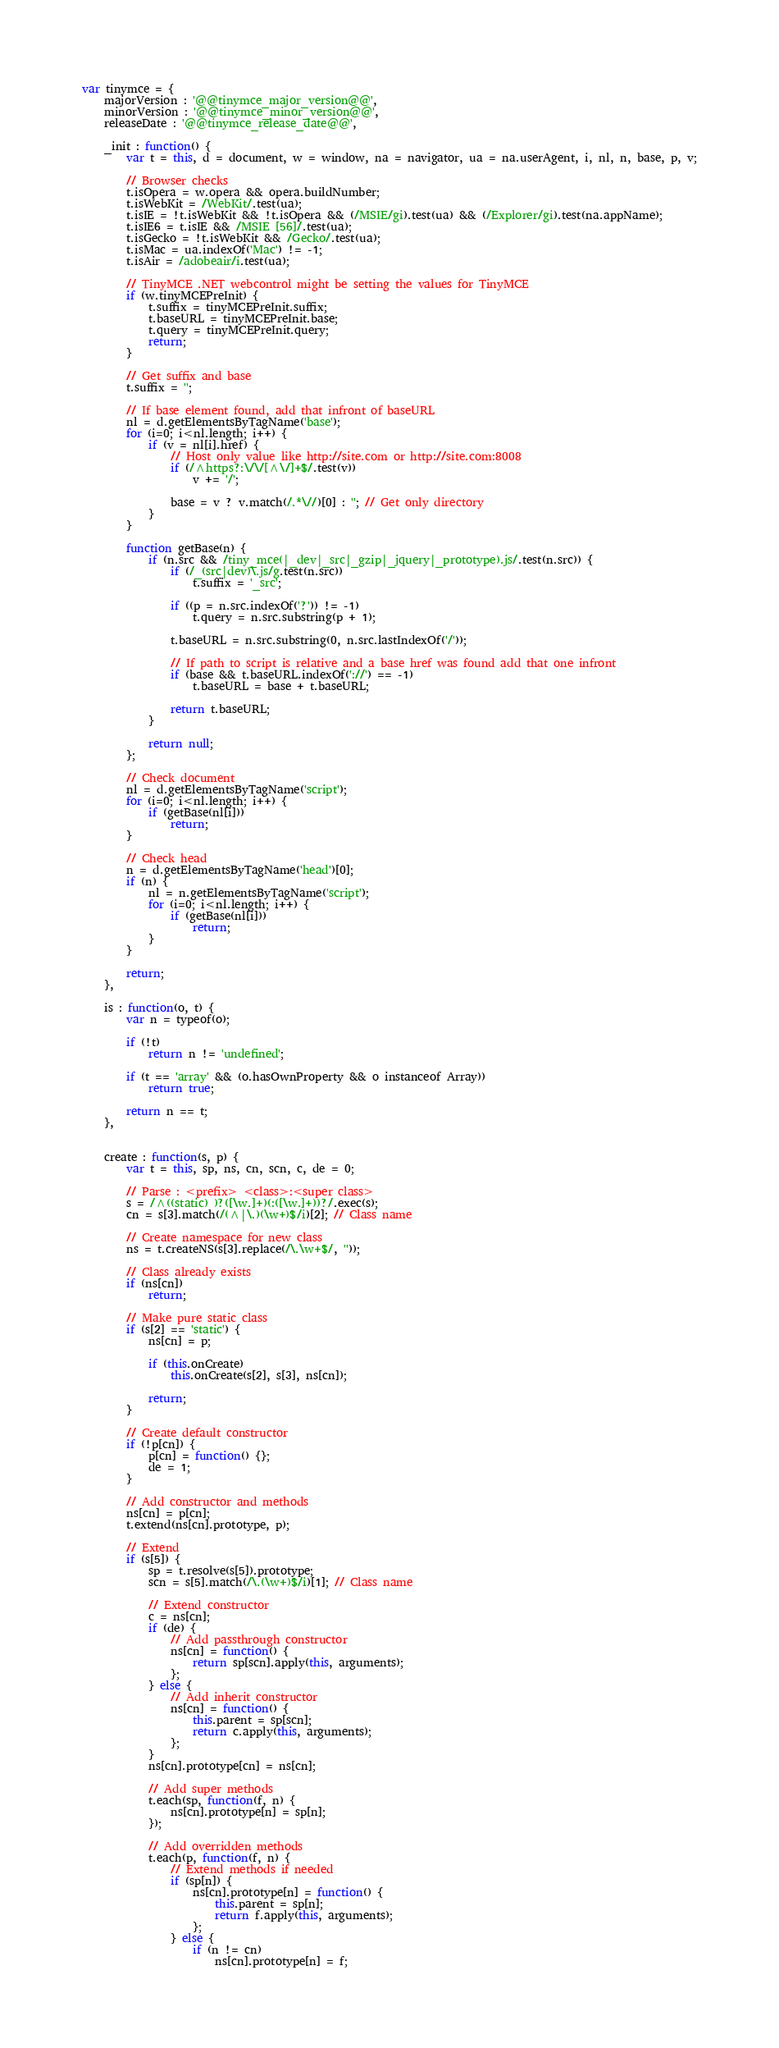<code> <loc_0><loc_0><loc_500><loc_500><_JavaScript_>var tinymce = {
	majorVersion : '@@tinymce_major_version@@',
	minorVersion : '@@tinymce_minor_version@@',
	releaseDate : '@@tinymce_release_date@@',

	_init : function() {
		var t = this, d = document, w = window, na = navigator, ua = na.userAgent, i, nl, n, base, p, v;

		// Browser checks
		t.isOpera = w.opera && opera.buildNumber;
		t.isWebKit = /WebKit/.test(ua);
		t.isIE = !t.isWebKit && !t.isOpera && (/MSIE/gi).test(ua) && (/Explorer/gi).test(na.appName);
		t.isIE6 = t.isIE && /MSIE [56]/.test(ua);
		t.isGecko = !t.isWebKit && /Gecko/.test(ua);
		t.isMac = ua.indexOf('Mac') != -1;
		t.isAir = /adobeair/i.test(ua);

		// TinyMCE .NET webcontrol might be setting the values for TinyMCE
		if (w.tinyMCEPreInit) {
			t.suffix = tinyMCEPreInit.suffix;
			t.baseURL = tinyMCEPreInit.base;
			t.query = tinyMCEPreInit.query;
			return;
		}

		// Get suffix and base
		t.suffix = '';

		// If base element found, add that infront of baseURL
		nl = d.getElementsByTagName('base');
		for (i=0; i<nl.length; i++) {
			if (v = nl[i].href) {
				// Host only value like http://site.com or http://site.com:8008
				if (/^https?:\/\/[^\/]+$/.test(v))
					v += '/';

				base = v ? v.match(/.*\//)[0] : ''; // Get only directory
			}
		}

		function getBase(n) {
			if (n.src && /tiny_mce(|_dev|_src|_gzip|_jquery|_prototype).js/.test(n.src)) {
				if (/_(src|dev)\.js/g.test(n.src))
					t.suffix = '_src';

				if ((p = n.src.indexOf('?')) != -1)
					t.query = n.src.substring(p + 1);

				t.baseURL = n.src.substring(0, n.src.lastIndexOf('/'));

				// If path to script is relative and a base href was found add that one infront
				if (base && t.baseURL.indexOf('://') == -1)
					t.baseURL = base + t.baseURL;

				return t.baseURL;
			}

			return null;
		};

		// Check document
		nl = d.getElementsByTagName('script');
		for (i=0; i<nl.length; i++) {
			if (getBase(nl[i]))
				return;
		}

		// Check head
		n = d.getElementsByTagName('head')[0];
		if (n) {
			nl = n.getElementsByTagName('script');
			for (i=0; i<nl.length; i++) {
				if (getBase(nl[i]))
					return;
			}
		}

		return;
	},

	is : function(o, t) {
		var n = typeof(o);

		if (!t)
			return n != 'undefined';

		if (t == 'array' && (o.hasOwnProperty && o instanceof Array))
			return true;

		return n == t;
	},


	create : function(s, p) {
		var t = this, sp, ns, cn, scn, c, de = 0;

		// Parse : <prefix> <class>:<super class>
		s = /^((static) )?([\w.]+)(:([\w.]+))?/.exec(s);
		cn = s[3].match(/(^|\.)(\w+)$/i)[2]; // Class name

		// Create namespace for new class
		ns = t.createNS(s[3].replace(/\.\w+$/, ''));

		// Class already exists
		if (ns[cn])
			return;

		// Make pure static class
		if (s[2] == 'static') {
			ns[cn] = p;

			if (this.onCreate)
				this.onCreate(s[2], s[3], ns[cn]);

			return;
		}

		// Create default constructor
		if (!p[cn]) {
			p[cn] = function() {};
			de = 1;
		}

		// Add constructor and methods
		ns[cn] = p[cn];
		t.extend(ns[cn].prototype, p);

		// Extend
		if (s[5]) {
			sp = t.resolve(s[5]).prototype;
			scn = s[5].match(/\.(\w+)$/i)[1]; // Class name

			// Extend constructor
			c = ns[cn];
			if (de) {
				// Add passthrough constructor
				ns[cn] = function() {
					return sp[scn].apply(this, arguments);
				};
			} else {
				// Add inherit constructor
				ns[cn] = function() {
					this.parent = sp[scn];
					return c.apply(this, arguments);
				};
			}
			ns[cn].prototype[cn] = ns[cn];

			// Add super methods
			t.each(sp, function(f, n) {
				ns[cn].prototype[n] = sp[n];
			});

			// Add overridden methods
			t.each(p, function(f, n) {
				// Extend methods if needed
				if (sp[n]) {
					ns[cn].prototype[n] = function() {
						this.parent = sp[n];
						return f.apply(this, arguments);
					};
				} else {
					if (n != cn)
						ns[cn].prototype[n] = f;</code> 